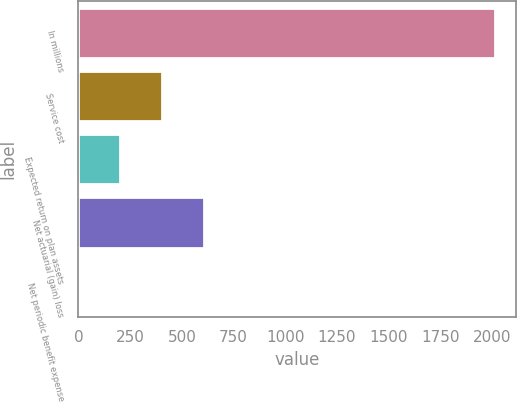<chart> <loc_0><loc_0><loc_500><loc_500><bar_chart><fcel>In millions<fcel>Service cost<fcel>Expected return on plan assets<fcel>Net actuarial (gain) loss<fcel>Net periodic benefit expense<nl><fcel>2015<fcel>403.72<fcel>202.31<fcel>605.13<fcel>0.9<nl></chart> 